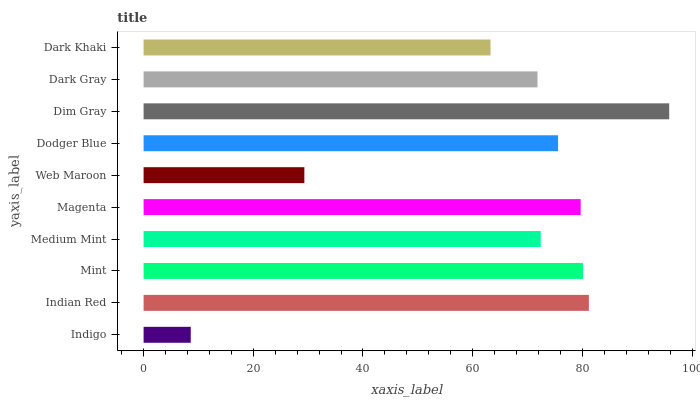Is Indigo the minimum?
Answer yes or no. Yes. Is Dim Gray the maximum?
Answer yes or no. Yes. Is Indian Red the minimum?
Answer yes or no. No. Is Indian Red the maximum?
Answer yes or no. No. Is Indian Red greater than Indigo?
Answer yes or no. Yes. Is Indigo less than Indian Red?
Answer yes or no. Yes. Is Indigo greater than Indian Red?
Answer yes or no. No. Is Indian Red less than Indigo?
Answer yes or no. No. Is Dodger Blue the high median?
Answer yes or no. Yes. Is Medium Mint the low median?
Answer yes or no. Yes. Is Indian Red the high median?
Answer yes or no. No. Is Web Maroon the low median?
Answer yes or no. No. 